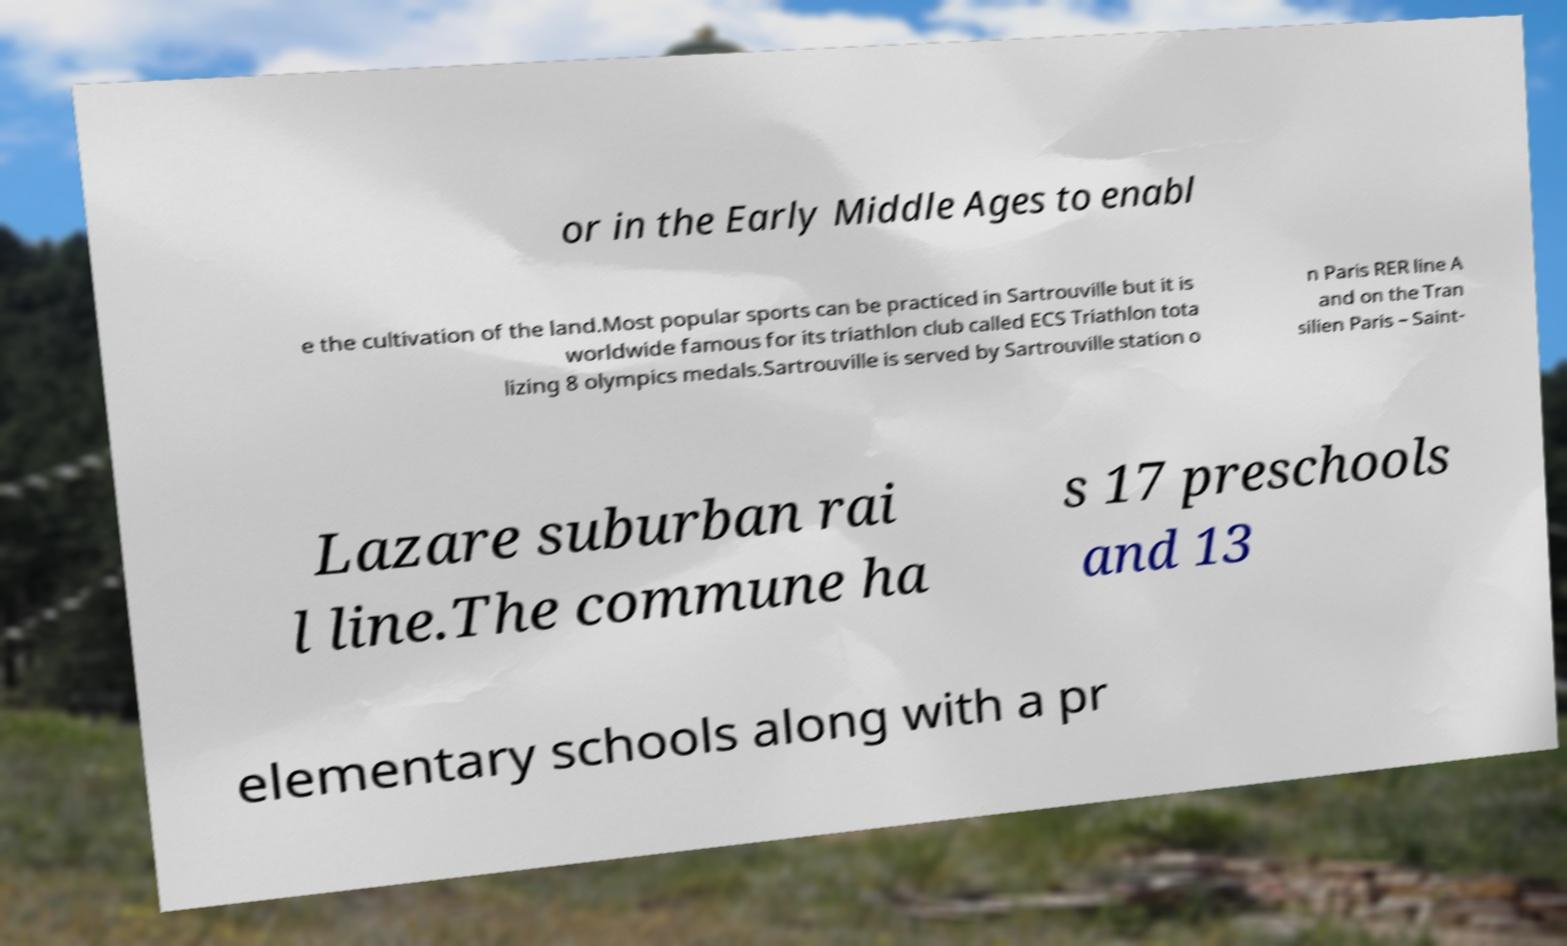Can you accurately transcribe the text from the provided image for me? or in the Early Middle Ages to enabl e the cultivation of the land.Most popular sports can be practiced in Sartrouville but it is worldwide famous for its triathlon club called ECS Triathlon tota lizing 8 olympics medals.Sartrouville is served by Sartrouville station o n Paris RER line A and on the Tran silien Paris – Saint- Lazare suburban rai l line.The commune ha s 17 preschools and 13 elementary schools along with a pr 